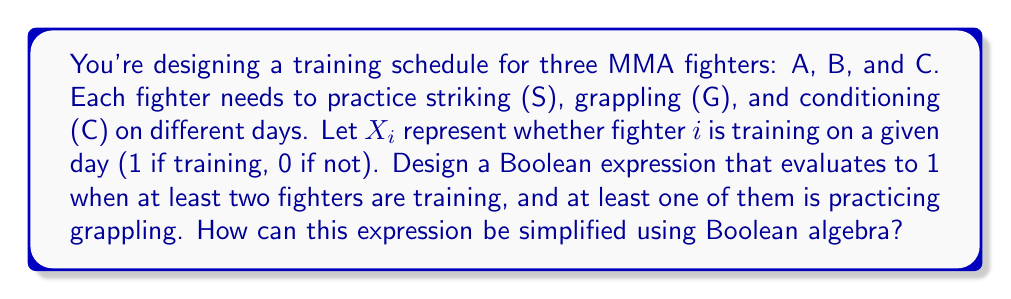Teach me how to tackle this problem. Let's approach this step-by-step:

1) First, we need to express "at least two fighters are training":
   $$(X_A \wedge X_B) \vee (X_B \wedge X_C) \vee (X_A \wedge X_C)$$

2) Next, we need to express "at least one of them is practicing grappling":
   $$(X_A \wedge G_A) \vee (X_B \wedge G_B) \vee (X_C \wedge G_C)$$

3) Combining these conditions with AND ($\wedge$):
   $$((X_A \wedge X_B) \vee (X_B \wedge X_C) \vee (X_A \wedge X_C)) \wedge ((X_A \wedge G_A) \vee (X_B \wedge G_B) \vee (X_C \wedge G_C))$$

4) Using the distributive property of Boolean algebra:
   $$(X_A \wedge X_B \wedge G_A) \vee (X_A \wedge X_B \wedge G_B) \vee$$
   $$(X_B \wedge X_C \wedge G_B) \vee (X_B \wedge X_C \wedge G_C) \vee$$
   $$(X_A \wedge X_C \wedge G_A) \vee (X_A \wedge X_C \wedge G_C)$$

5) This expression can be simplified by recognizing that if a fighter is grappling, they are also training. So $X_i \wedge G_i$ can be simplified to $G_i$:
   $$(X_A \wedge X_B \wedge G_A) \vee (X_A \wedge X_B \wedge G_B) \vee$$
   $$(X_B \wedge X_C \wedge G_B) \vee (X_B \wedge X_C \wedge G_C) \vee$$
   $$(X_A \wedge X_C \wedge G_A) \vee (X_A \wedge X_C \wedge G_C)$$

This is the simplified Boolean expression that represents the desired training schedule condition.
Answer: $$(X_A \wedge X_B \wedge G_A) \vee (X_A \wedge X_B \wedge G_B) \vee (X_B \wedge X_C \wedge G_B) \vee (X_B \wedge X_C \wedge G_C) \vee (X_A \wedge X_C \wedge G_A) \vee (X_A \wedge X_C \wedge G_C)$$ 